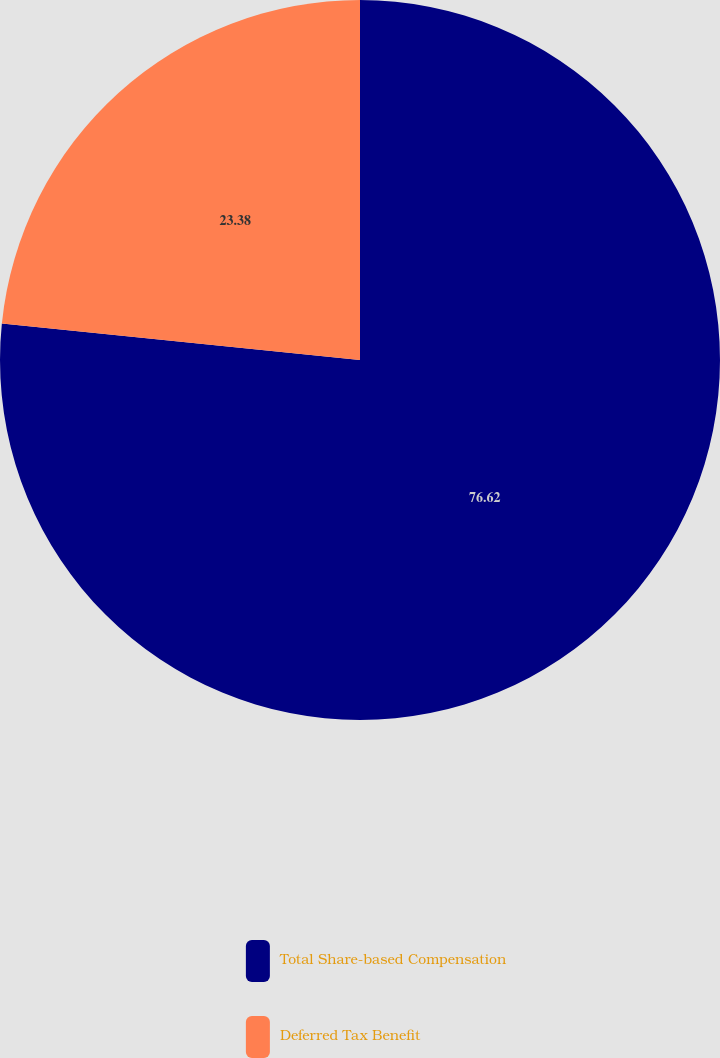Convert chart. <chart><loc_0><loc_0><loc_500><loc_500><pie_chart><fcel>Total Share-based Compensation<fcel>Deferred Tax Benefit<nl><fcel>76.62%<fcel>23.38%<nl></chart> 